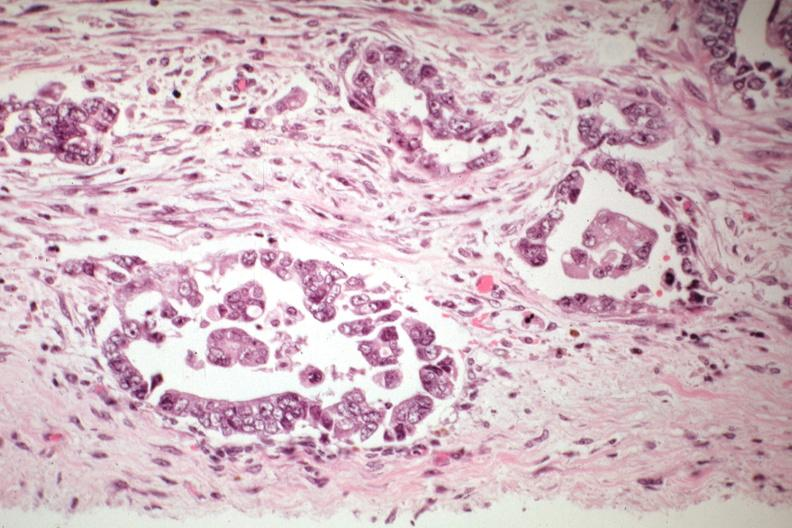s female reproductive present?
Answer the question using a single word or phrase. Yes 